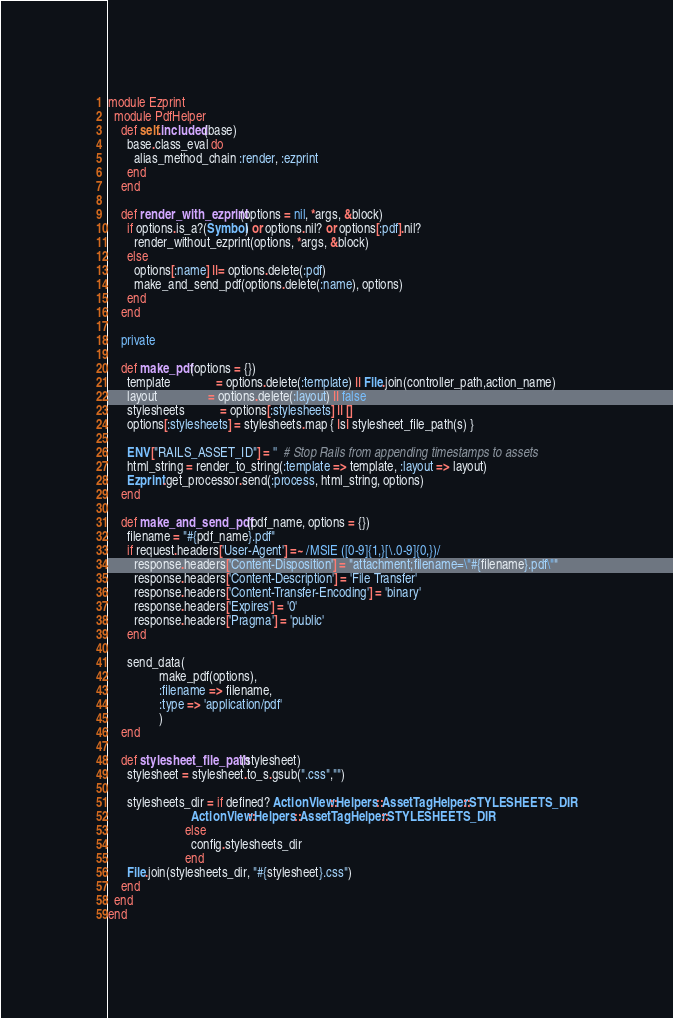<code> <loc_0><loc_0><loc_500><loc_500><_Ruby_>module Ezprint
  module PdfHelper
    def self.included(base)
      base.class_eval do
        alias_method_chain :render, :ezprint
      end
    end

    def render_with_ezprint(options = nil, *args, &block)
      if options.is_a?(Symbol) or options.nil? or options[:pdf].nil?
        render_without_ezprint(options, *args, &block)
      else
        options[:name] ||= options.delete(:pdf)
        make_and_send_pdf(options.delete(:name), options)
      end
    end

    private

    def make_pdf(options = {})
      template              = options.delete(:template) || File.join(controller_path,action_name)
      layout                = options.delete(:layout) || false
      stylesheets           = options[:stylesheets] || []
      options[:stylesheets] = stylesheets.map { |s| stylesheet_file_path(s) }

      ENV["RAILS_ASSET_ID"] = ''  # Stop Rails from appending timestamps to assets
      html_string = render_to_string(:template => template, :layout => layout)
      Ezprint.get_processor.send(:process, html_string, options)
    end

    def make_and_send_pdf(pdf_name, options = {})
      filename = "#{pdf_name}.pdf"
      if request.headers['User-Agent'] =~ /MSIE ([0-9]{1,}[\.0-9]{0,})/
        response.headers['Content-Disposition'] = "attachment;filename=\"#{filename}.pdf\""
        response.headers['Content-Description'] = 'File Transfer'
        response.headers['Content-Transfer-Encoding'] = 'binary'
        response.headers['Expires'] = '0'
        response.headers['Pragma'] = 'public'
      end

      send_data(
                make_pdf(options),
                :filename => filename,
                :type => 'application/pdf'
                )
    end

    def stylesheet_file_path(stylesheet)
      stylesheet = stylesheet.to_s.gsub(".css","")

      stylesheets_dir = if defined? ActionView::Helpers::AssetTagHelper::STYLESHEETS_DIR
                          ActionView::Helpers::AssetTagHelper::STYLESHEETS_DIR
                        else
                          config.stylesheets_dir
                        end
      File.join(stylesheets_dir, "#{stylesheet}.css")
    end
  end
end
</code> 